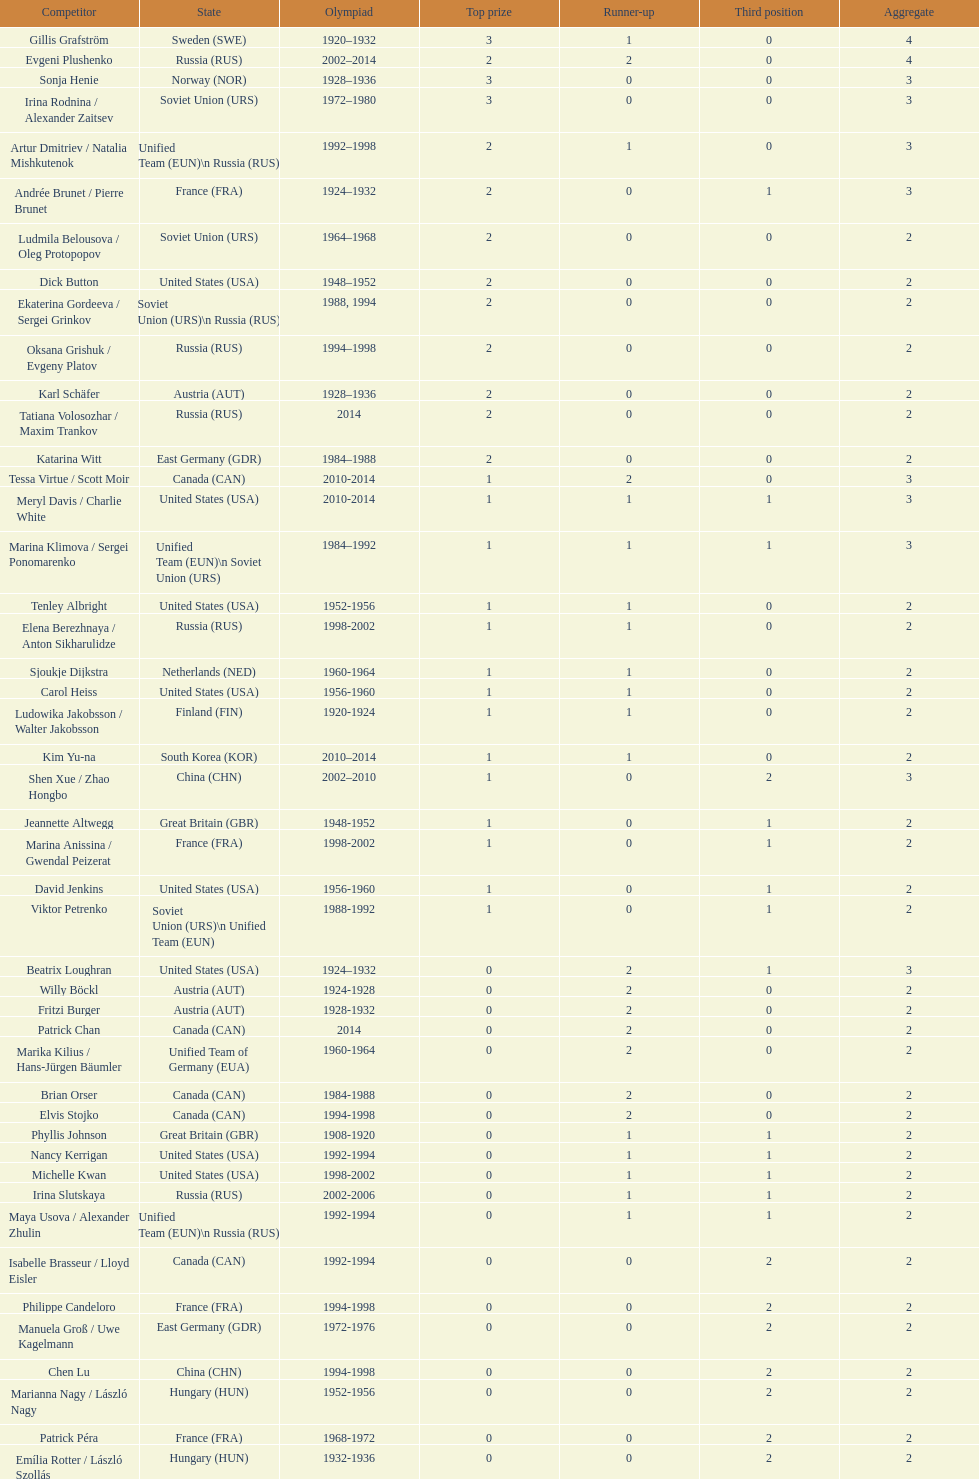What was the greatest number of gold medals won by a single athlete? 3. 